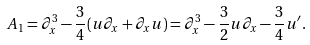Convert formula to latex. <formula><loc_0><loc_0><loc_500><loc_500>A _ { 1 } = \partial _ { x } ^ { 3 } - \frac { 3 } { 4 } ( u \partial _ { x } + \partial _ { x } u ) = \partial _ { x } ^ { 3 } - \frac { 3 } { 2 } u \partial _ { x } - \frac { 3 } { 4 } u ^ { \prime } .</formula> 